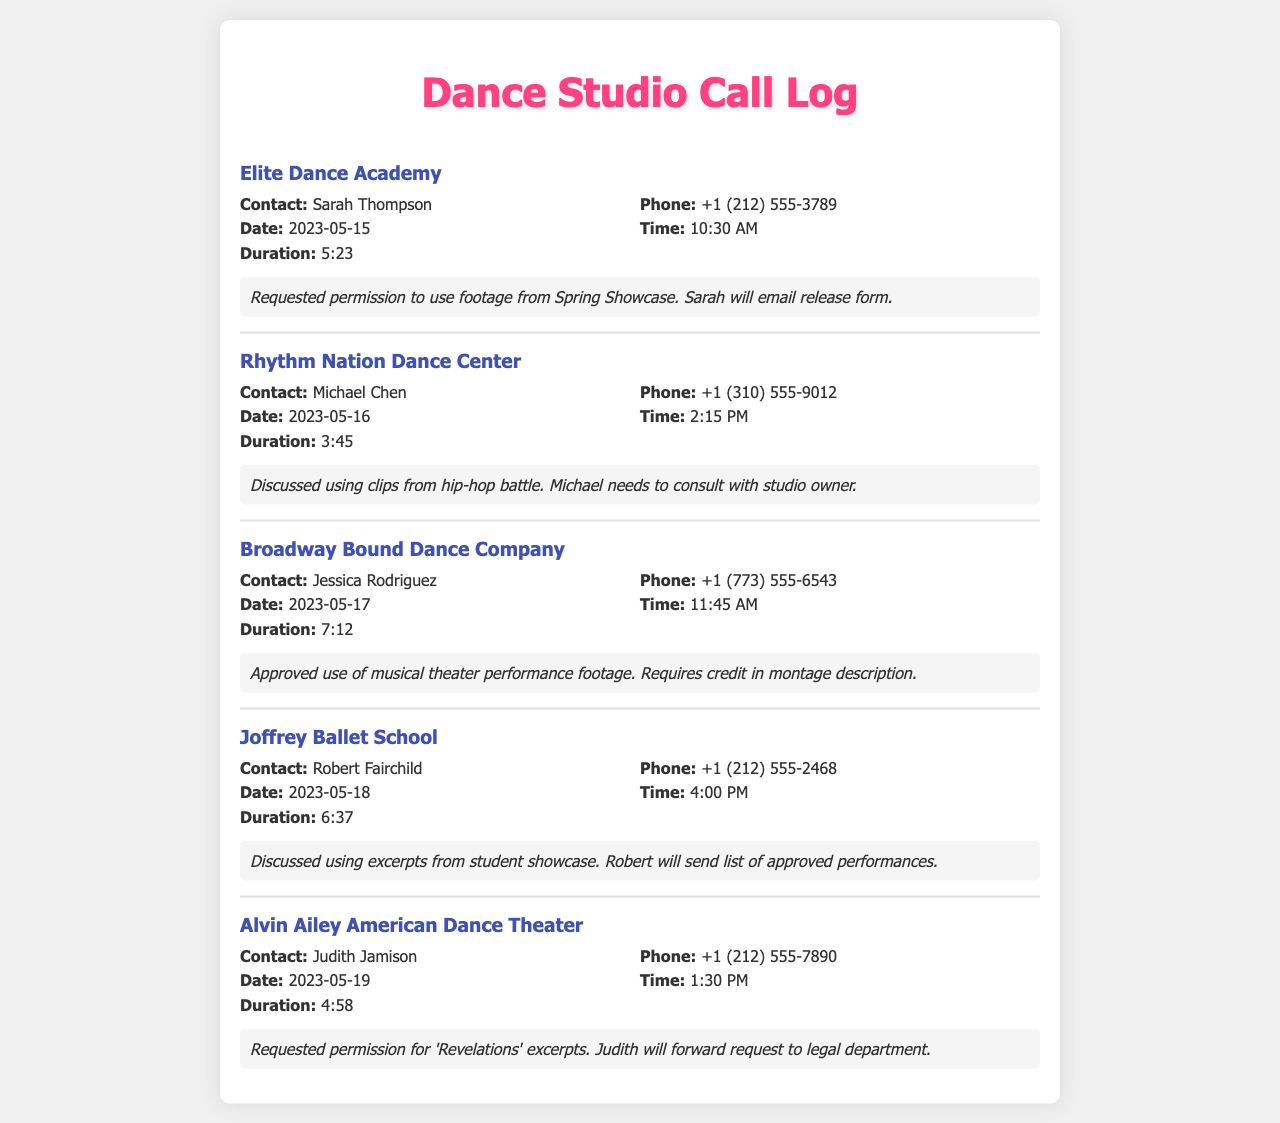what is the contact name for Elite Dance Academy? The contact name is listed in the call log for Elite Dance Academy as Sarah Thompson.
Answer: Sarah Thompson what is the phone number for Rhythm Nation Dance Center? The phone number is specifically provided in the call log for Rhythm Nation Dance Center as +1 (310) 555-9012.
Answer: +1 (310) 555-9012 on what date was the call to Joffrey Ballet School made? The date of the call is indicated as 2023-05-18 in the call log for Joffrey Ballet School.
Answer: 2023-05-18 how long was the call to Broadway Bound Dance Company? The duration of the call is stated in the call log as 7:12 for Broadway Bound Dance Company.
Answer: 7:12 which studio required credit in the montage description? The call log indicates that Broadway Bound Dance Company requires credit in the montage description.
Answer: Broadway Bound Dance Company who will send the list of approved performances from Joffrey Ballet School? The call log mentions that Robert Fairchild will send the list of approved performances.
Answer: Robert Fairchild what was discussed during the call to Rhythm Nation Dance Center? The discussion topic is noted in the call log as using clips from the hip-hop battle.
Answer: using clips from hip-hop battle what is the result of the call to Alvin Ailey American Dance Theater? The outcome of the call is outlined in the call log, indicating that Judith will forward the request to the legal department.
Answer: Judith will forward request to legal department when did the call to Elite Dance Academy take place? The time of the call is recorded as 10:30 AM in the call log for Elite Dance Academy.
Answer: 10:30 AM 